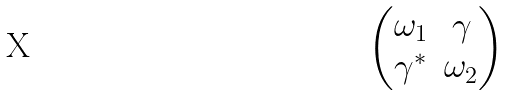Convert formula to latex. <formula><loc_0><loc_0><loc_500><loc_500>\begin{pmatrix} \omega _ { 1 } & \gamma \\ \gamma ^ { * } & \omega _ { 2 } \end{pmatrix}</formula> 